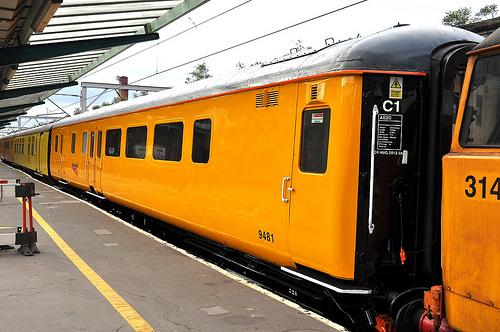What kind of location do you infer this image was taken at, based on the objects present? This image was likely taken at a train station platform, as there are train cars, a platform with a yellow line, a red and black barrier, and electrical wires above the train. What are the numbers displayed on the train, and what are their colors? The numbers displayed on the train are 314, in black, and 9481, also in black. What type of objects can be seen on the ground in the image? A red and black barrier, a yellow line painted on the platform, and two stains on the pavement can be seen on the ground in the image. Estimate the number of visible train windows and describe any additional features they may have. There are at least three visible train windows, one of which has a sticker on it. What sentiment or emotion does this image evoke, if any? The image may evoke a sense of anticipation or waiting since the train is stopped at the platform, possibly in preparation for passenger boarding. Mention an object interaction that occurs within the image, if applicable. A pin attaching the train cars interacts with them, connecting them together. Describe the handles visible on the train and their surroundings. A small chrome handle and a silver door handle are visible on the train's door, a large handrail is close to the designation c1, and a long vertical handle is shown near a yellow border. List the different types of shapes, symbols, or landmarks visible in the image and their locations. A yellow and black triangle on a white sticker is near the c1 designation, tree tops can be seen in the upper right corner, and electrical wires are above the train. 